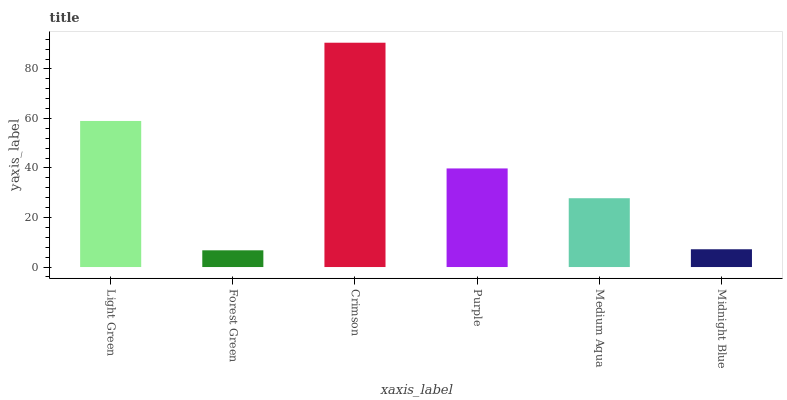Is Forest Green the minimum?
Answer yes or no. Yes. Is Crimson the maximum?
Answer yes or no. Yes. Is Crimson the minimum?
Answer yes or no. No. Is Forest Green the maximum?
Answer yes or no. No. Is Crimson greater than Forest Green?
Answer yes or no. Yes. Is Forest Green less than Crimson?
Answer yes or no. Yes. Is Forest Green greater than Crimson?
Answer yes or no. No. Is Crimson less than Forest Green?
Answer yes or no. No. Is Purple the high median?
Answer yes or no. Yes. Is Medium Aqua the low median?
Answer yes or no. Yes. Is Midnight Blue the high median?
Answer yes or no. No. Is Purple the low median?
Answer yes or no. No. 